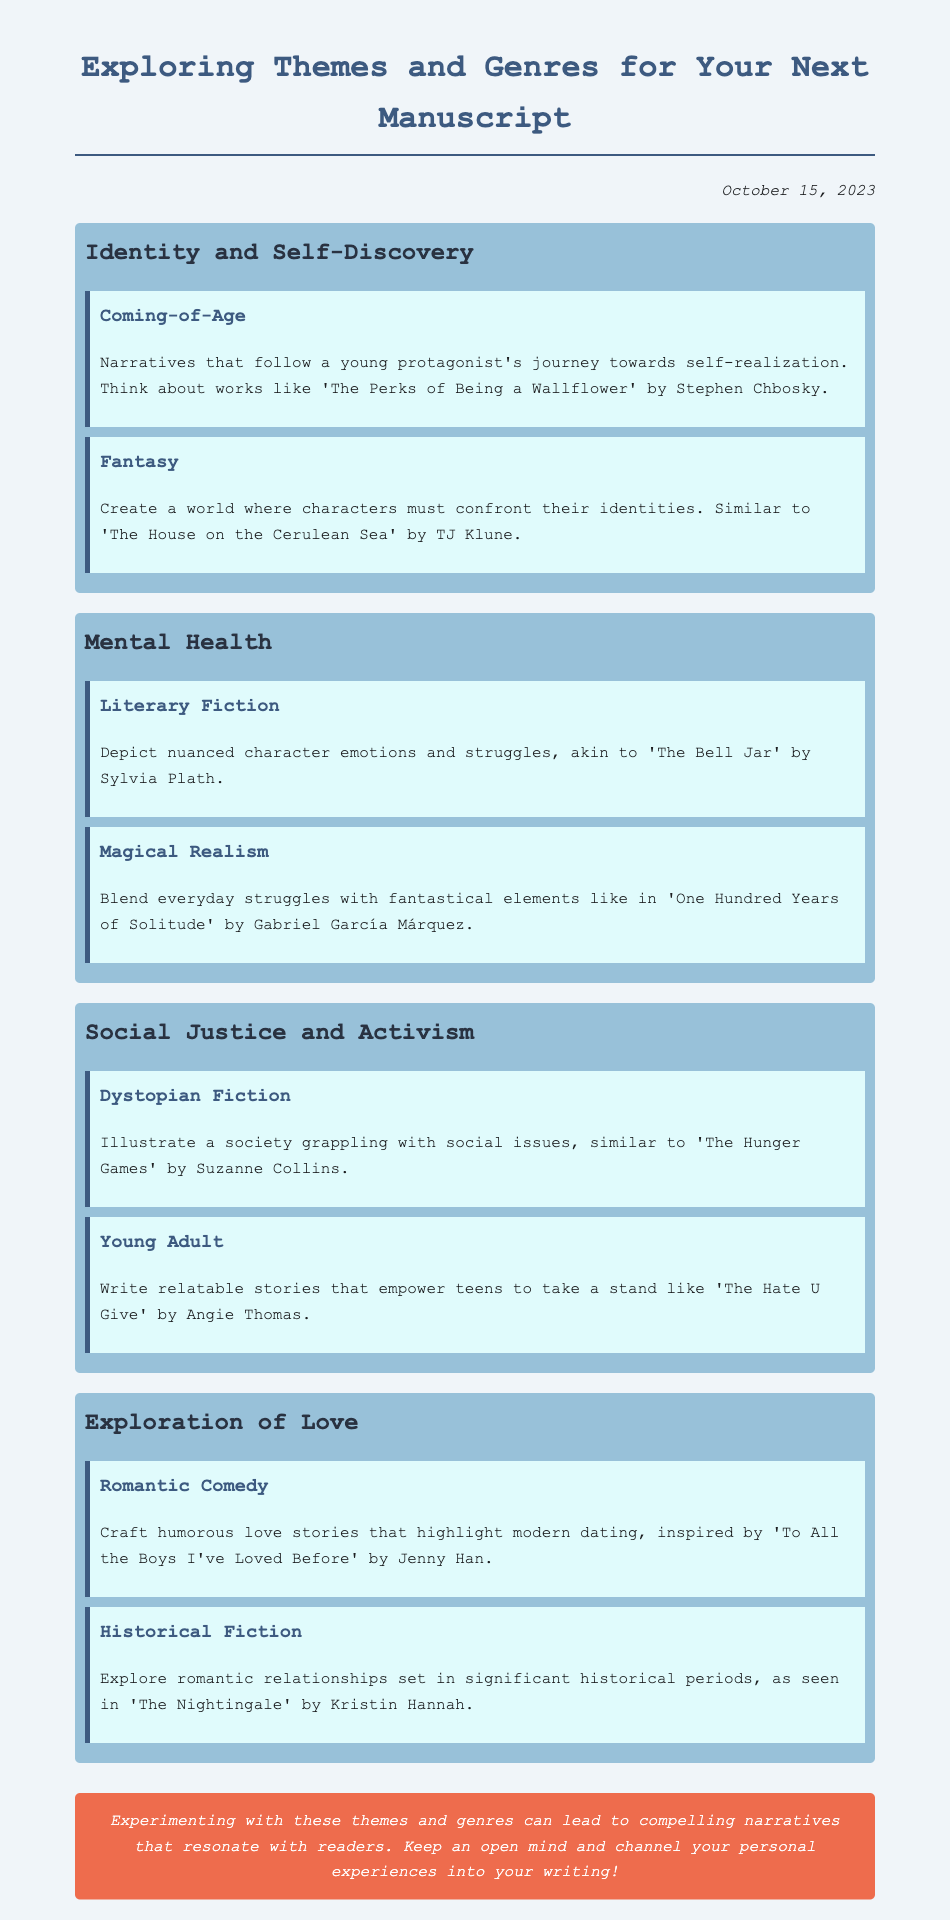What is the date of the brainstorming session? The date mentioned in the document is indicated in the date section at the top.
Answer: October 15, 2023 What theme is associated with 'The Perks of Being a Wallflower'? 'The Perks of Being a Wallflower' is mentioned as an example under the theme of Identity and Self-Discovery.
Answer: Identity and Self-Discovery Which genre is linked to 'One Hundred Years of Solitude'? The genre associated with 'One Hundred Years of Solitude' appears in the Mental Health theme.
Answer: Magical Realism Name one dystopian fiction example mentioned. The document cites 'The Hunger Games' by Suzanne Collins as an example of dystopian fiction under the Social Justice and Activism theme.
Answer: The Hunger Games What is a common aspect of romantic comedies described? The document suggests that romantic comedies highlight modern dating experiences, which is a common aspect mentioned.
Answer: Humorous love stories Which theme features coming-of-age narratives? Coming-of-age narratives are specifically mentioned under the theme of Identity and Self-Discovery in the document.
Answer: Identity and Self-Discovery What type of writing does the document encourage for exploring personal experiences? The closing thoughts section advocates for channeling personal experiences into any writing related to the themes or genres discussed.
Answer: Experimenting What is the overall suggestion in the closing thoughts? The closing thoughts emphasize the importance of experimenting with themes and genres to create compelling narratives.
Answer: Keep an open mind 